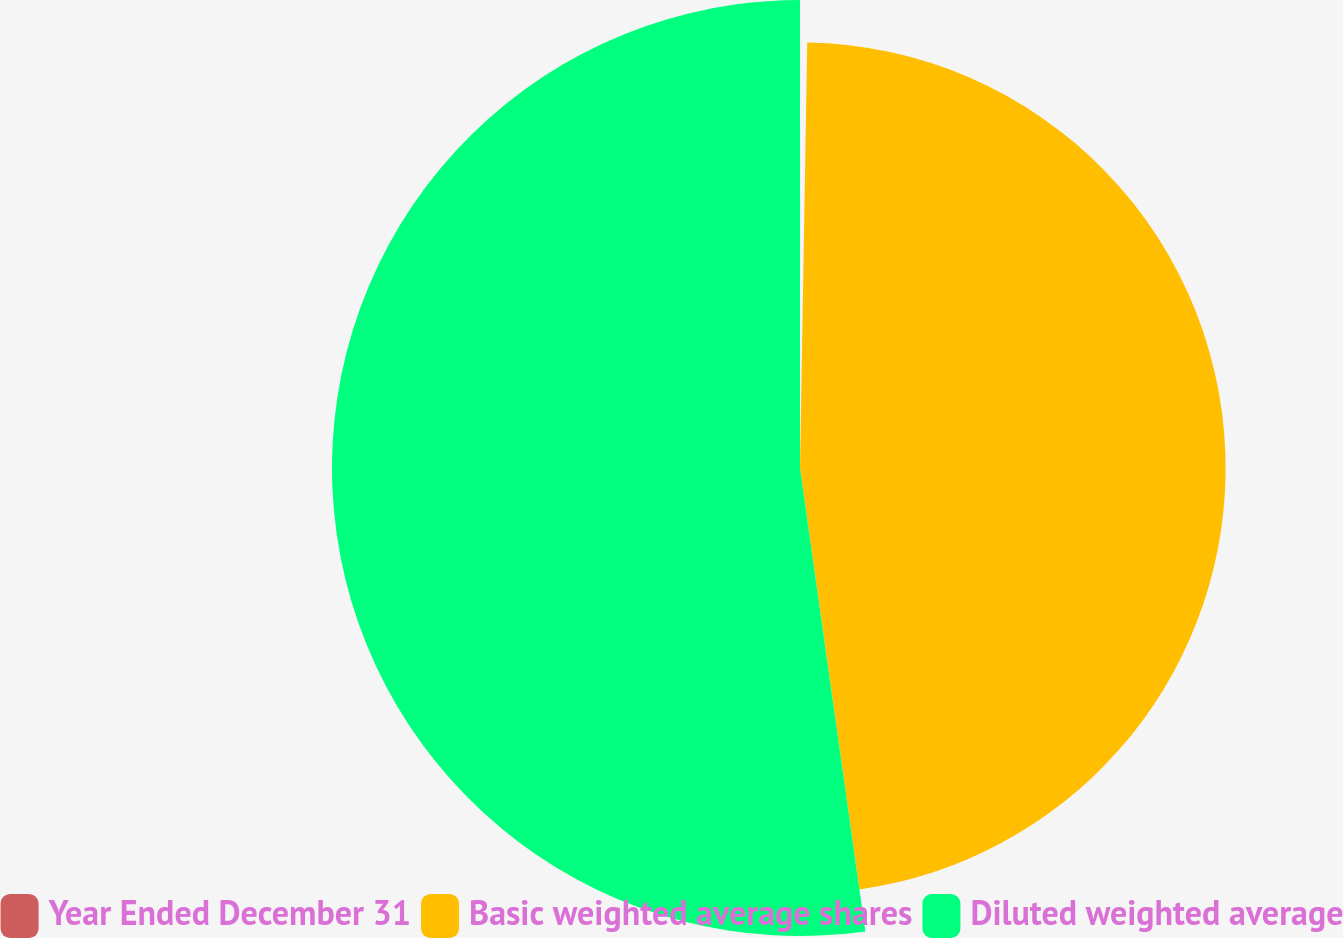<chart> <loc_0><loc_0><loc_500><loc_500><pie_chart><fcel>Year Ended December 31<fcel>Basic weighted average shares<fcel>Diluted weighted average<nl><fcel>0.27%<fcel>47.5%<fcel>52.23%<nl></chart> 